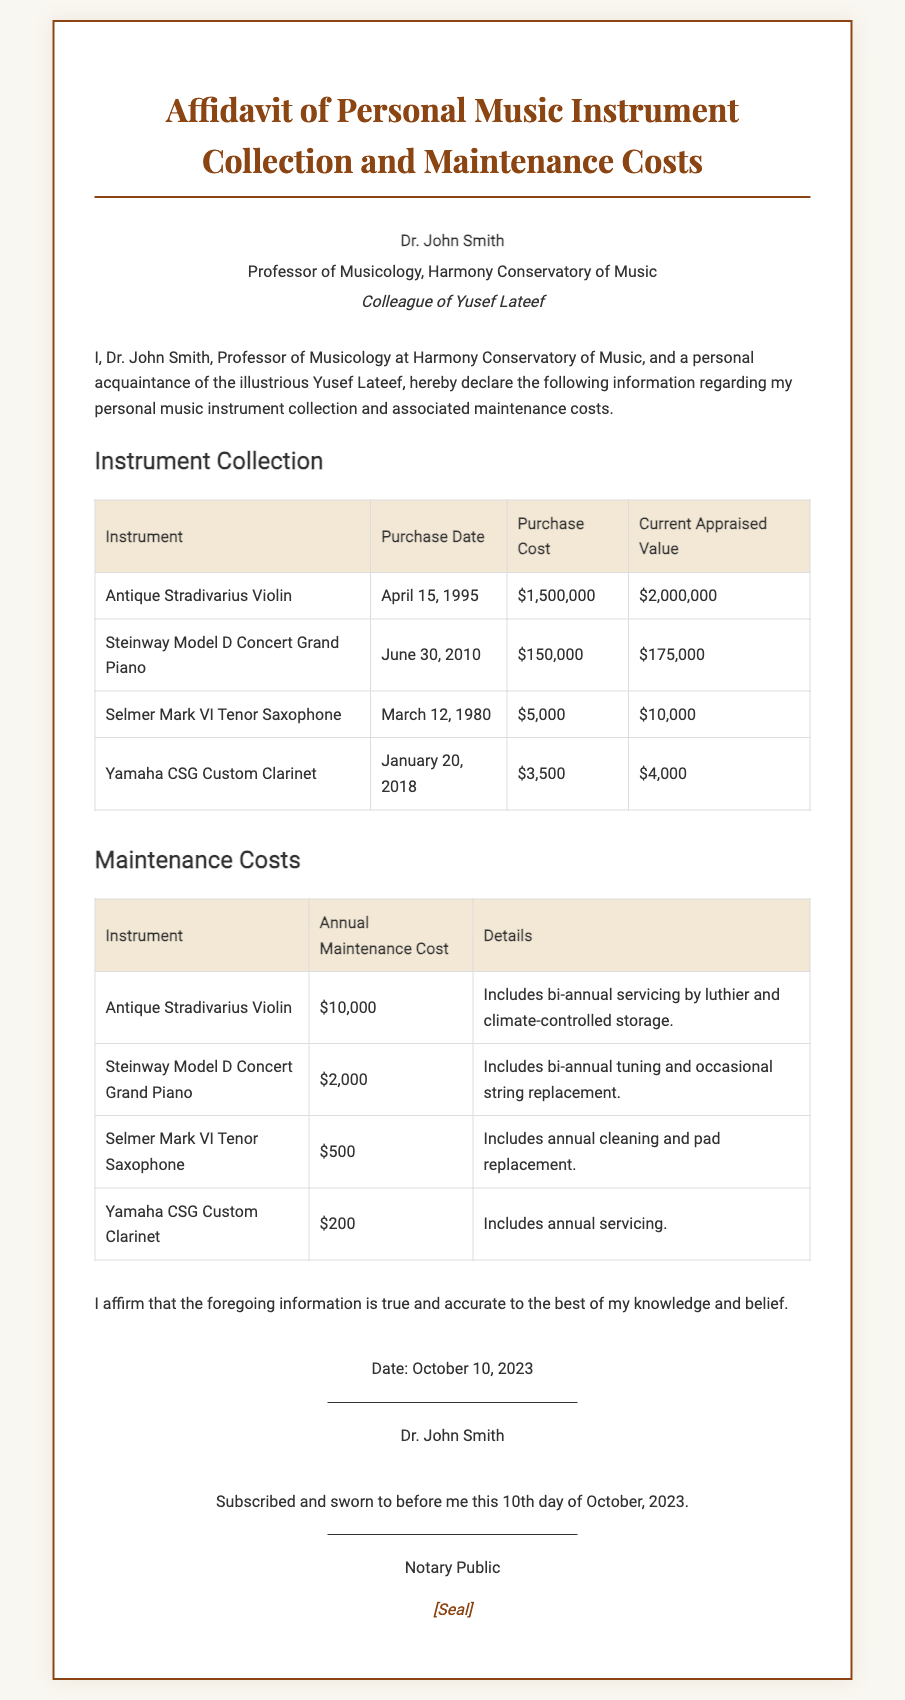What is the name of the affiant? The affiant's name is stated in the document as Dr. John Smith.
Answer: Dr. John Smith What is the purchase date of the Antique Stradivarius Violin? The purchase date is provided in the instrument table for the Antique Stradivarius Violin.
Answer: April 15, 1995 What is the annual maintenance cost for the Yamaha CSG Custom Clarinet? The annual maintenance cost is specified in the maintenance costs table for the Yamaha CSG Custom Clarinet.
Answer: $200 What is the current appraised value of the Selmer Mark VI Tenor Saxophone? The appraised value is listed in the instrument table for the Selmer Mark VI Tenor Saxophone.
Answer: $10,000 How much did the Steinway Model D Concert Grand Piano cost at purchase? The purchase cost is indicated in the instrument table for the Steinway Model D Concert Grand Piano.
Answer: $150,000 Who is a colleague of Yusef Lateef mentioned in the affidavit? The colleague of Yusef Lateef is Dr. John Smith, as stated in the affiant info.
Answer: Dr. John Smith What is included in the maintenance cost for the Antique Stradivarius Violin? The details of the maintenance cost for the Antique Stradivarius Violin are provided in the maintenance costs table.
Answer: Bi-annual servicing by luthier and climate-controlled storage On what date was the affidavit signed? The date of signing is found in the signature section of the affidavit.
Answer: October 10, 2023 What information does the notary section contain? The notary section contains the verification details that the affidavit was subscribed and sworn to, along with a signature line.
Answer: Subscribed and sworn to before me this 10th day of October, 2023 